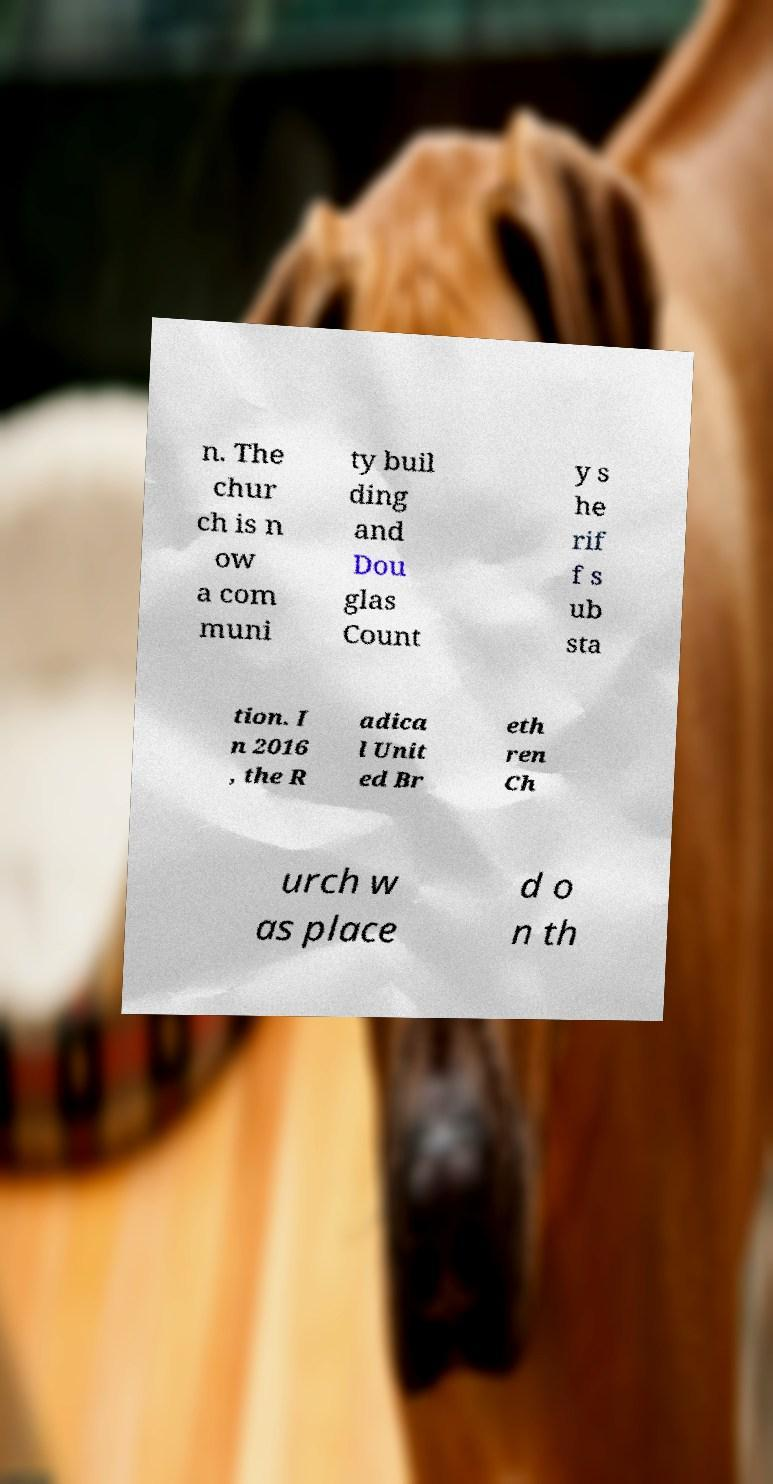What messages or text are displayed in this image? I need them in a readable, typed format. n. The chur ch is n ow a com muni ty buil ding and Dou glas Count y s he rif f s ub sta tion. I n 2016 , the R adica l Unit ed Br eth ren Ch urch w as place d o n th 